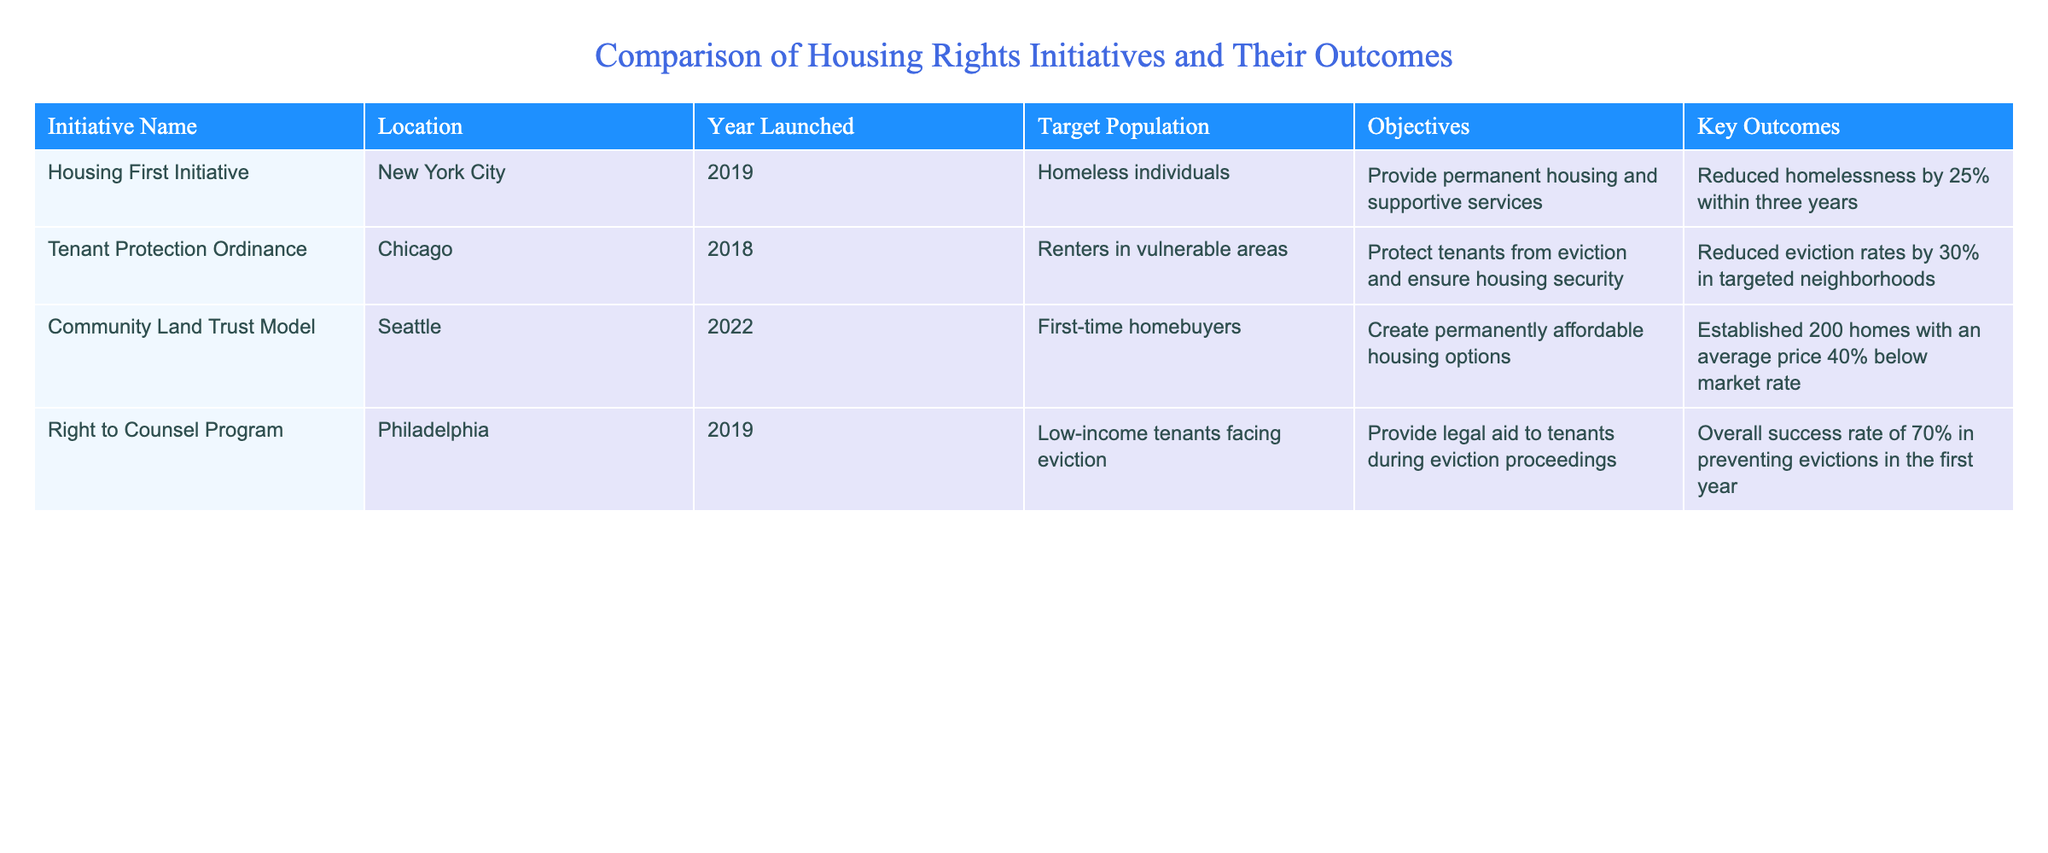What is the key outcome of the Housing First Initiative launched in New York City? The Housing First Initiative's key outcome is a 25% reduction in homelessness within three years. This information is directly stated in the table under the corresponding column for the initiative.
Answer: Reduced homelessness by 25% within three years Which initiative had the objective of protecting renters in vulnerable areas? The Tenant Protection Ordinance, launched in Chicago, aimed to protect renters in vulnerable areas from eviction and ensure housing security, as stated in the objectives column of the table.
Answer: Tenant Protection Ordinance Is it true that the Right to Counsel Program had a success rate of over 60% in preventing evictions? Yes, the Right to Counsel Program had an overall success rate of 70% in preventing evictions during its first year, which is above 60%. This fact can be verified from the data in the table.
Answer: Yes What was the average percentage reduction in eviction rates for the Tenant Protection Ordinance and the Right to Counsel Program combined? The Tenant Protection Ordinance reduced eviction rates by 30%, while the Right to Counsel Program had a success rate of 70% in preventing evictions. To find the average, we sum the two percentages (30 + 70 = 100) and divide by 2, resulting in an average of 50%.
Answer: 50% How many total homes were established by the Community Land Trust Model in Seattle? The Community Land Trust Model established a total of 200 homes, as mentioned in the key outcomes section of the table relevant to this initiative.
Answer: 200 homes Did any of the initiatives target first-time homebuyers? Yes, the Community Land Trust Model specifically targeted first-time homebuyers, as indicated in the target population column of the table.
Answer: Yes Which initiative achieved the highest percentage reduction in homelessness or eviction rates? The Right to Counsel Program achieved a 70% success rate in preventing evictions, which is higher than the outcomes of the other initiatives. This information can be compared across the key outcomes of each initiative listed in the table.
Answer: Right to Counsel Program What is the average price decrease of homes established by the Community Land Trust Model compared to the market rate? The Community Land Trust Model created homes at an average price that is 40% below the market rate. As this figure is stated as a singular percentage in the outcomes column, it represents the average price decrease directly.
Answer: 40% below market rate 